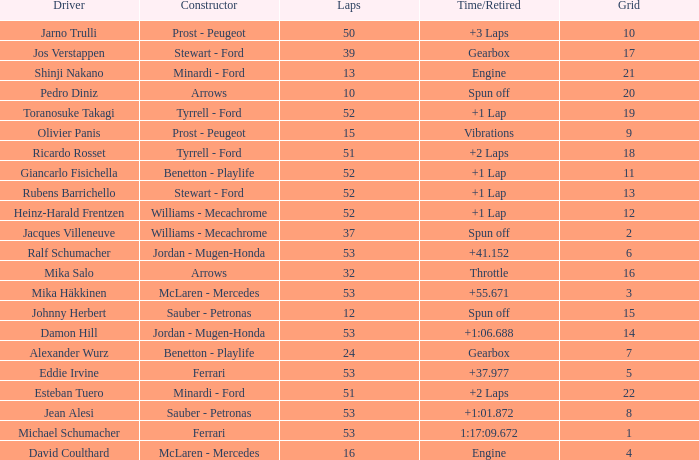What is the high lap total for pedro diniz? 10.0. 